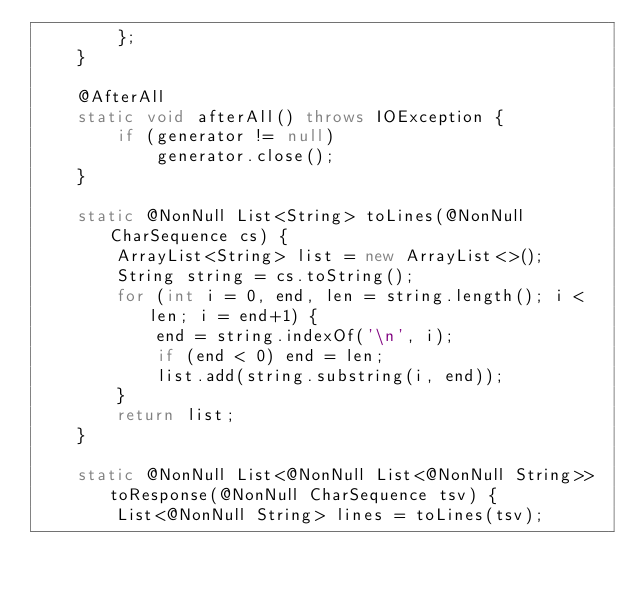Convert code to text. <code><loc_0><loc_0><loc_500><loc_500><_Java_>        };
    }

    @AfterAll
    static void afterAll() throws IOException {
        if (generator != null)
            generator.close();
    }

    static @NonNull List<String> toLines(@NonNull CharSequence cs) {
        ArrayList<String> list = new ArrayList<>();
        String string = cs.toString();
        for (int i = 0, end, len = string.length(); i < len; i = end+1) {
            end = string.indexOf('\n', i);
            if (end < 0) end = len;
            list.add(string.substring(i, end));
        }
        return list;
    }

    static @NonNull List<@NonNull List<@NonNull String>> toResponse(@NonNull CharSequence tsv) {
        List<@NonNull String> lines = toLines(tsv);
</code> 